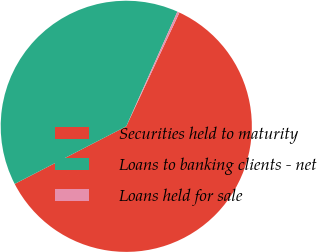Convert chart. <chart><loc_0><loc_0><loc_500><loc_500><pie_chart><fcel>Securities held to maturity<fcel>Loans to banking clients - net<fcel>Loans held for sale<nl><fcel>60.46%<fcel>39.26%<fcel>0.28%<nl></chart> 